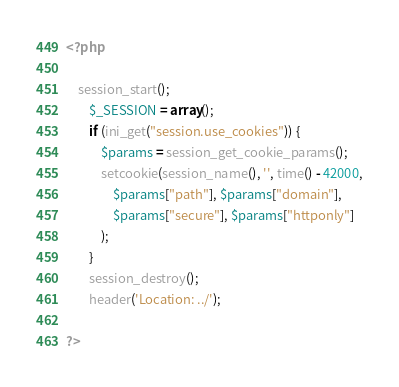Convert code to text. <code><loc_0><loc_0><loc_500><loc_500><_PHP_><?php

    session_start();
        $_SESSION = array();
        if (ini_get("session.use_cookies")) {
            $params = session_get_cookie_params();
            setcookie(session_name(), '', time() - 42000,
                $params["path"], $params["domain"],
                $params["secure"], $params["httponly"]
            );
        }
        session_destroy();
        header('Location: ../');

?></code> 